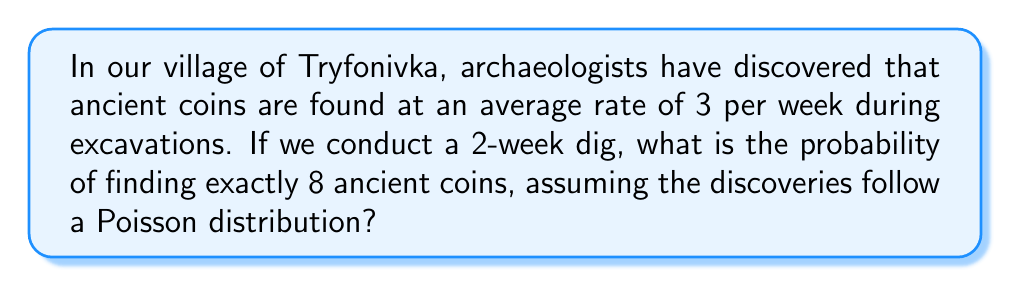Could you help me with this problem? Let's approach this step-by-step using the Poisson distribution:

1) The Poisson distribution is given by the formula:

   $$P(X = k) = \frac{e^{-\lambda} \lambda^k}{k!}$$

   where $\lambda$ is the average rate of occurrences and $k$ is the number of occurrences we're interested in.

2) In this case:
   - $\lambda = 3$ coins/week × 2 weeks = 6 coins for the entire period
   - $k = 8$ coins

3) Plugging these values into the formula:

   $$P(X = 8) = \frac{e^{-6} 6^8}{8!}$$

4) Let's calculate this step-by-step:
   
   $$\begin{align}
   P(X = 8) &= \frac{e^{-6} \times 6^8}{8!} \\
   &= \frac{0.00248 \times 1,679,616}{40,320} \\
   &= \frac{4,165.45}{40,320} \\
   &\approx 0.1033
   \end{align}$$

5) Convert to a percentage: 0.1033 × 100% ≈ 10.33%

Therefore, the probability of finding exactly 8 ancient coins during a 2-week dig in Tryfonivka is approximately 10.33%.
Answer: 10.33% 